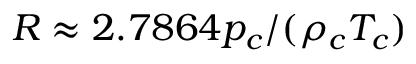<formula> <loc_0><loc_0><loc_500><loc_500>R \approx 2 . 7 8 6 4 p _ { c } / ( \rho _ { c } T _ { c } )</formula> 